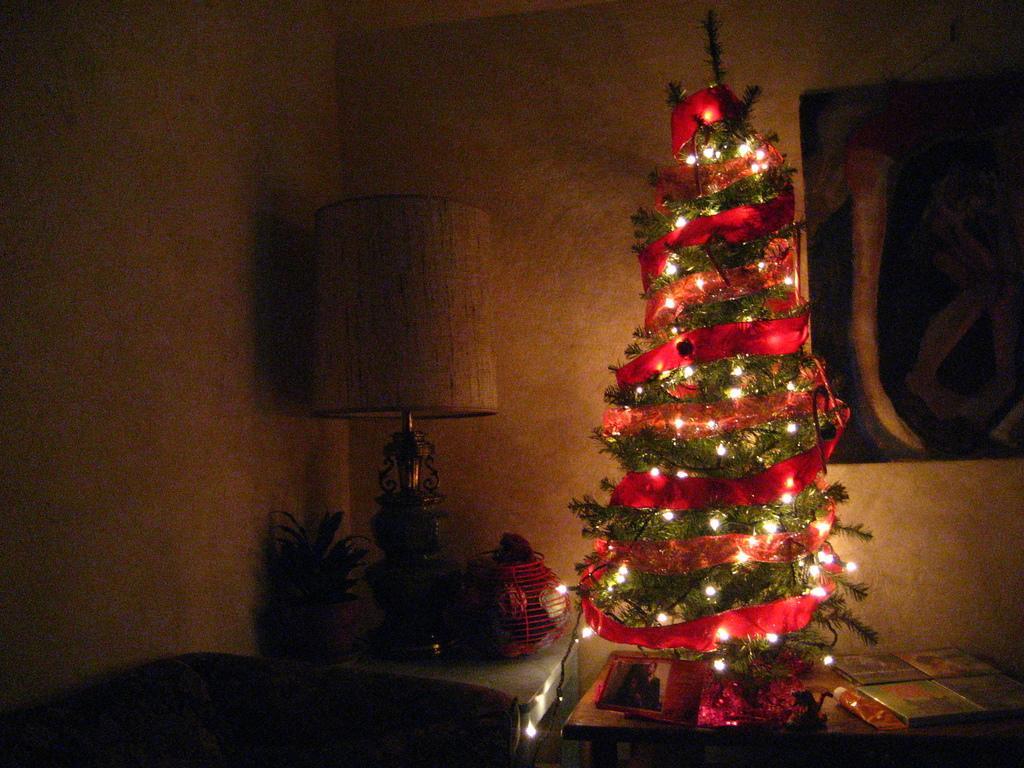How would you summarize this image in a sentence or two? In the center of the picture there is a christmas tree on a table decorated with lights and ribbons. On the right there are books and a frame. On the left there are lamp, flower pot and other objects. In the background it is well. 